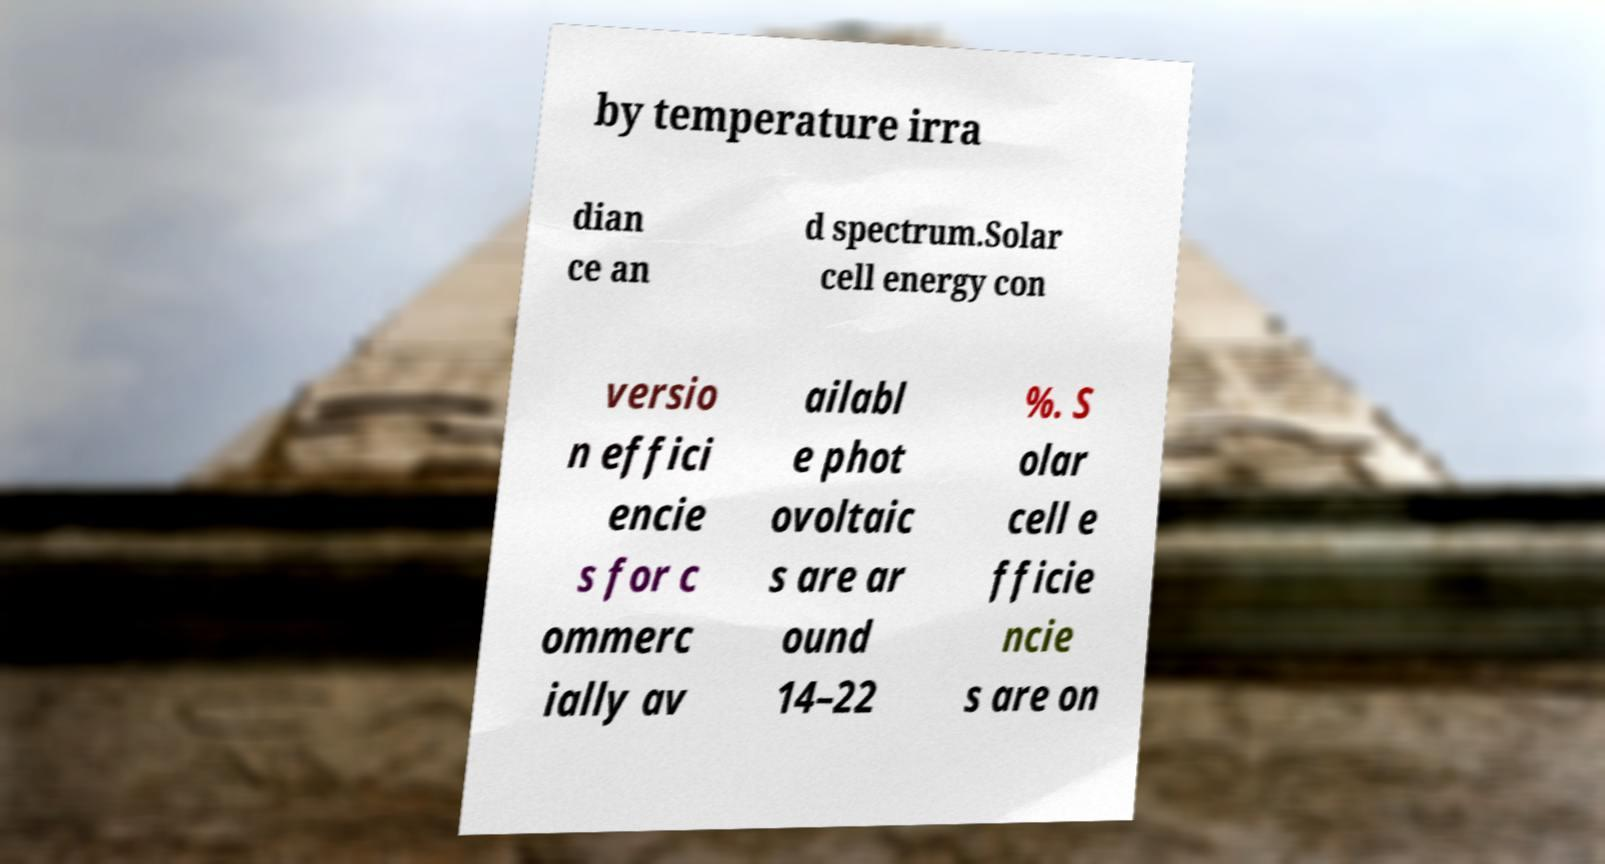Could you assist in decoding the text presented in this image and type it out clearly? by temperature irra dian ce an d spectrum.Solar cell energy con versio n effici encie s for c ommerc ially av ailabl e phot ovoltaic s are ar ound 14–22 %. S olar cell e fficie ncie s are on 